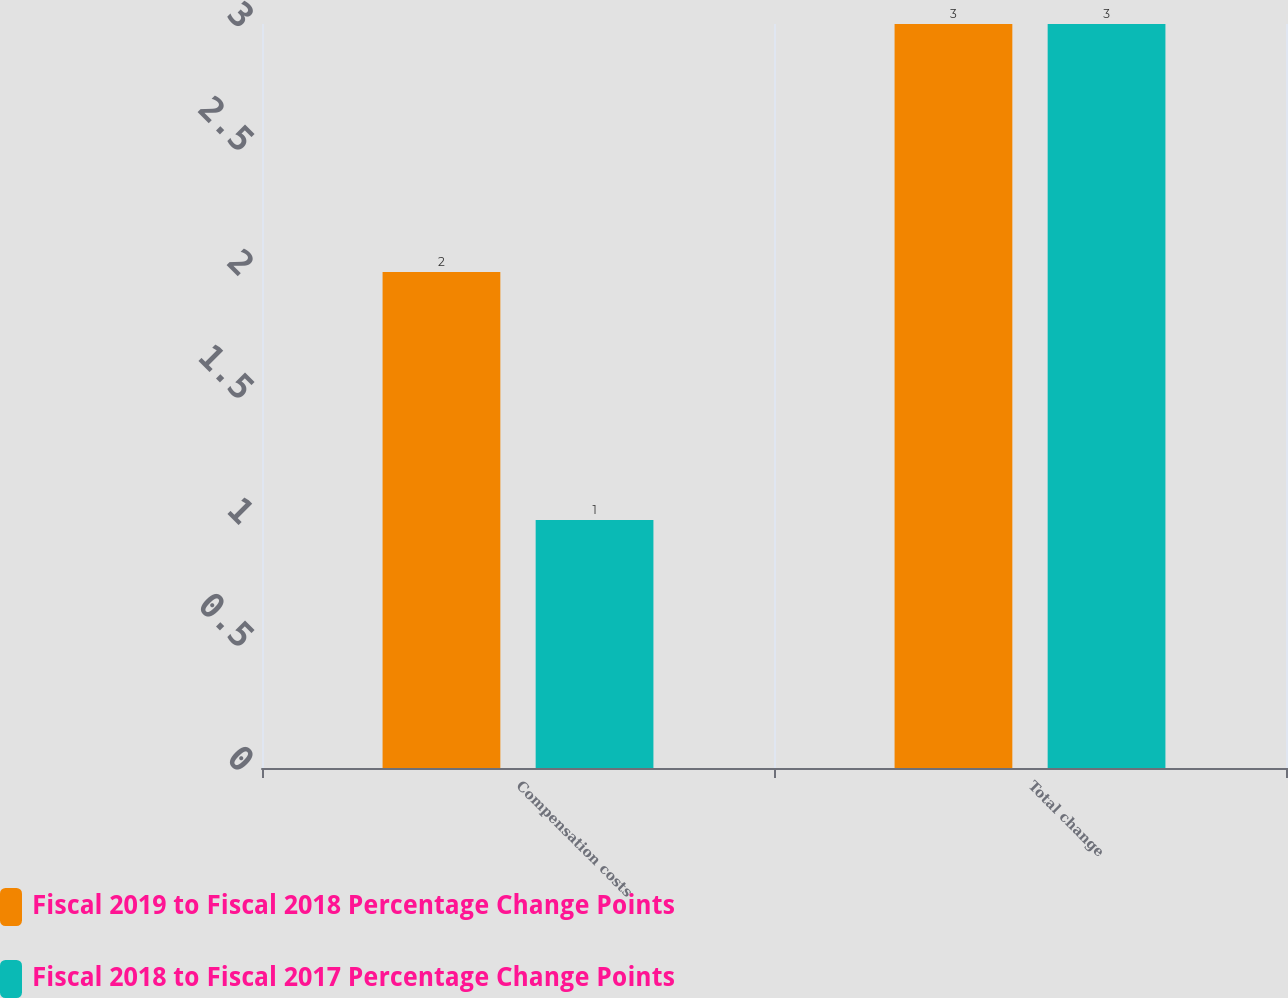Convert chart. <chart><loc_0><loc_0><loc_500><loc_500><stacked_bar_chart><ecel><fcel>Compensation costs<fcel>Total change<nl><fcel>Fiscal 2019 to Fiscal 2018 Percentage Change Points<fcel>2<fcel>3<nl><fcel>Fiscal 2018 to Fiscal 2017 Percentage Change Points<fcel>1<fcel>3<nl></chart> 